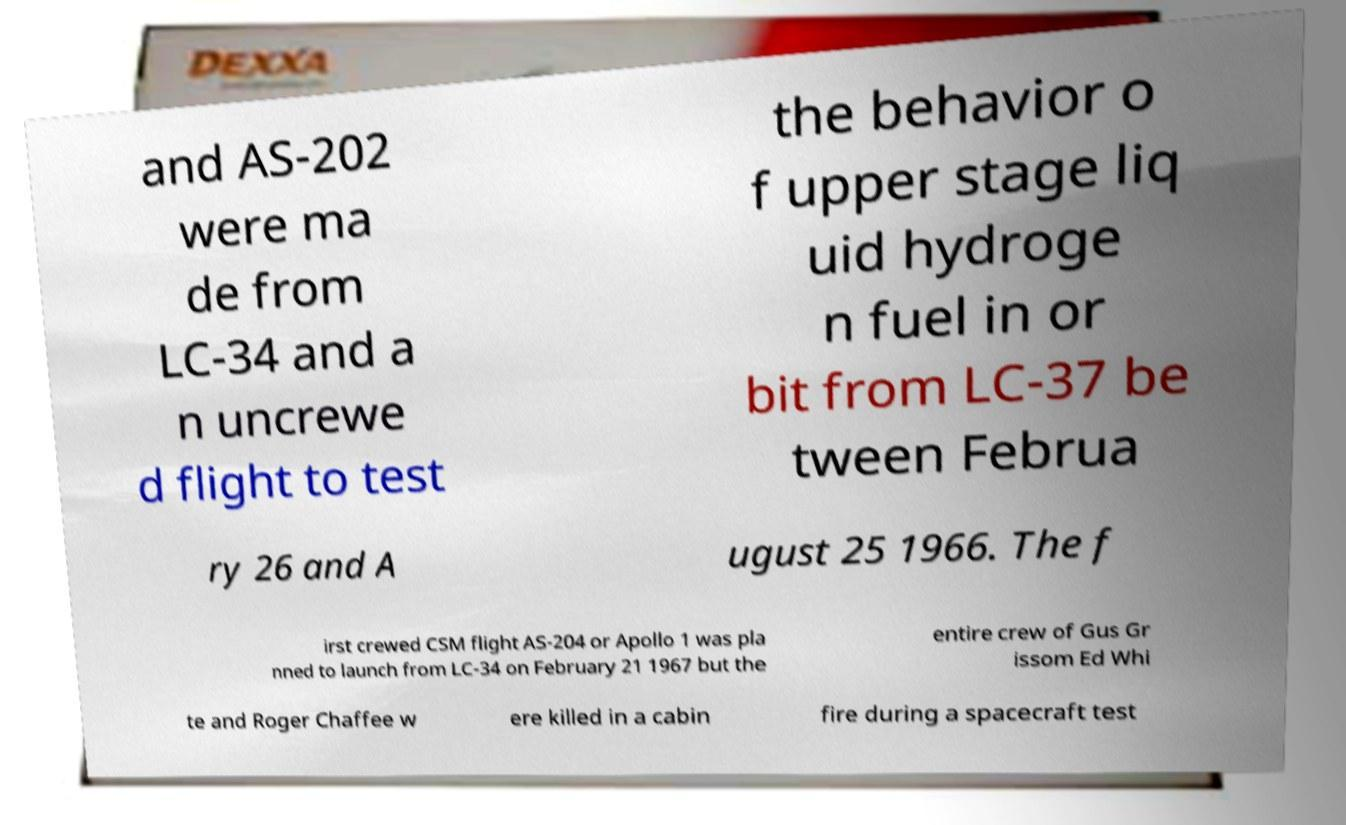Could you assist in decoding the text presented in this image and type it out clearly? and AS-202 were ma de from LC-34 and a n uncrewe d flight to test the behavior o f upper stage liq uid hydroge n fuel in or bit from LC-37 be tween Februa ry 26 and A ugust 25 1966. The f irst crewed CSM flight AS-204 or Apollo 1 was pla nned to launch from LC-34 on February 21 1967 but the entire crew of Gus Gr issom Ed Whi te and Roger Chaffee w ere killed in a cabin fire during a spacecraft test 